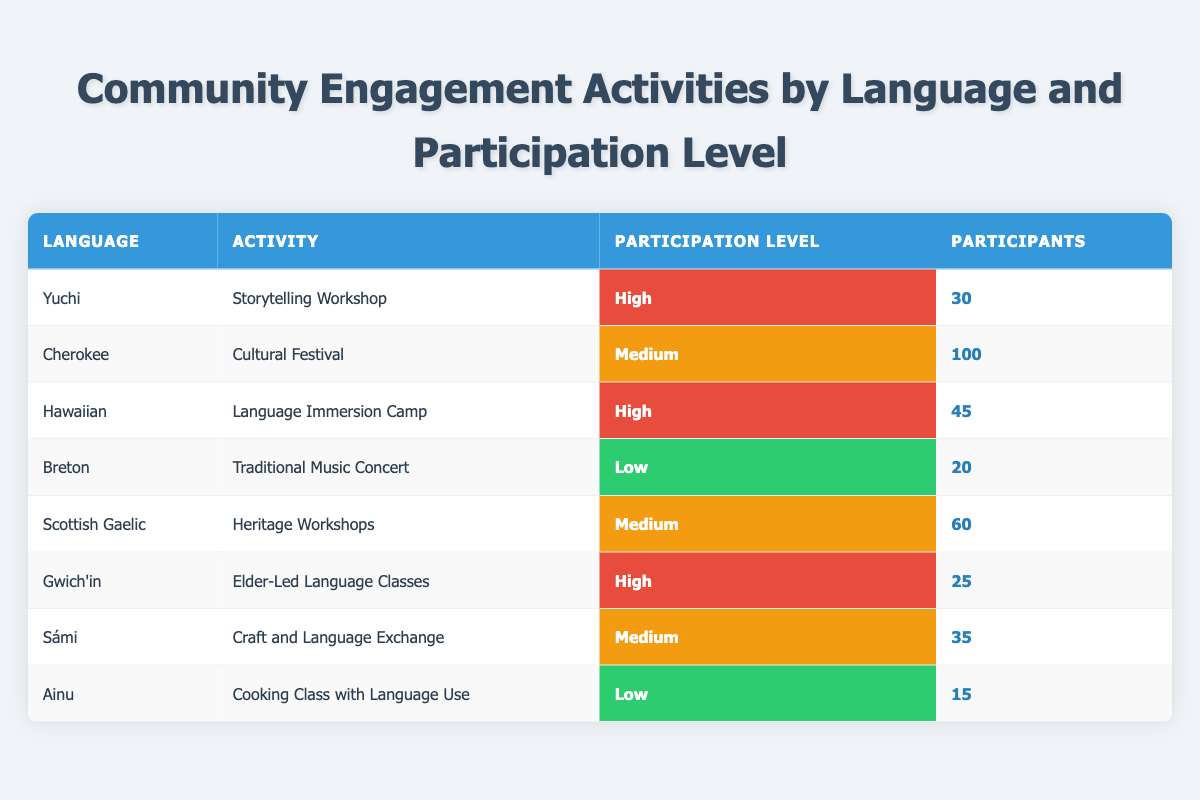What is the total number of participants in the storytelling workshop for the Yuchi language? The table shows that there are 30 participants in the storytelling workshop listed under the Yuchi language. Therefore, we can directly refer to this information.
Answer: 30 Which activity with a medium participation level had the highest number of participants? From the table, the activities classified as medium participation level are the Cultural Festival (100 participants), Heritage Workshops (60 participants), and Craft and Language Exchange (35 participants). Out of these, the Cultural Festival has the largest number, which is 100 participants.
Answer: Cultural Festival Is there any activity that had a low participation level with more than 20 participants? The low participation activities listed in the table are Traditional Music Concert (20 participants) and Cooking Class with Language Use (15 participants). Both activities fall under low participation, and neither exceeds 20 participants.
Answer: No How many total participants were engaged in high participation level activities? The high participation level activities are the Storytelling Workshop (30 participants), Language Immersion Camp (45 participants), and Elder-Led Language Classes (25 participants). Summing these gives us 30 + 45 + 25 = 100.
Answer: 100 Which language had the least number of participants engaged in community activities? The table shows that the Ainu language had the least number of participants in the cooking class with 15 participants, which is fewer than the 20 participants recorded for Breton. Thus, Ainu has the least overall.
Answer: Ainu 